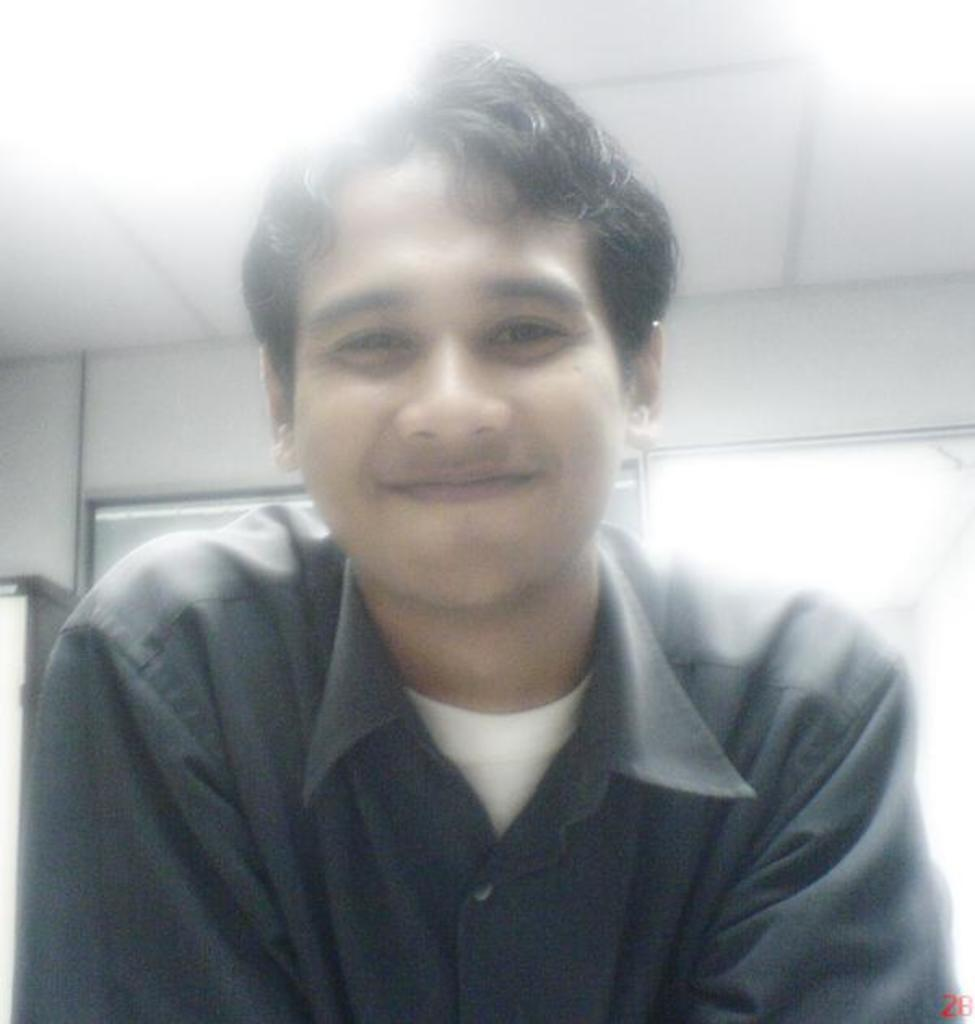What is present in the image? There is a person in the image. Can you describe the person's expression? The person has a smiling face. What type of mist can be seen surrounding the person in the image? There is no mist present in the image; it only features a person with a smiling face. 